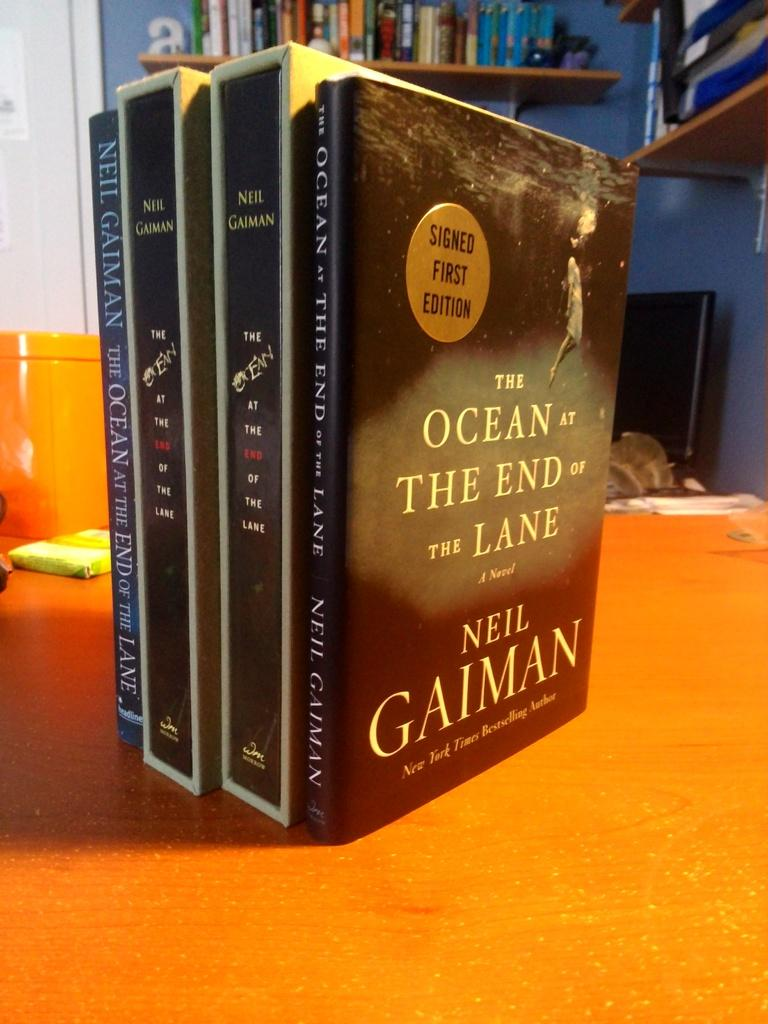<image>
Present a compact description of the photo's key features. Four copies if Neil Gaiman's The Ocean at the End of the Lane are staked side by side on a desk. 